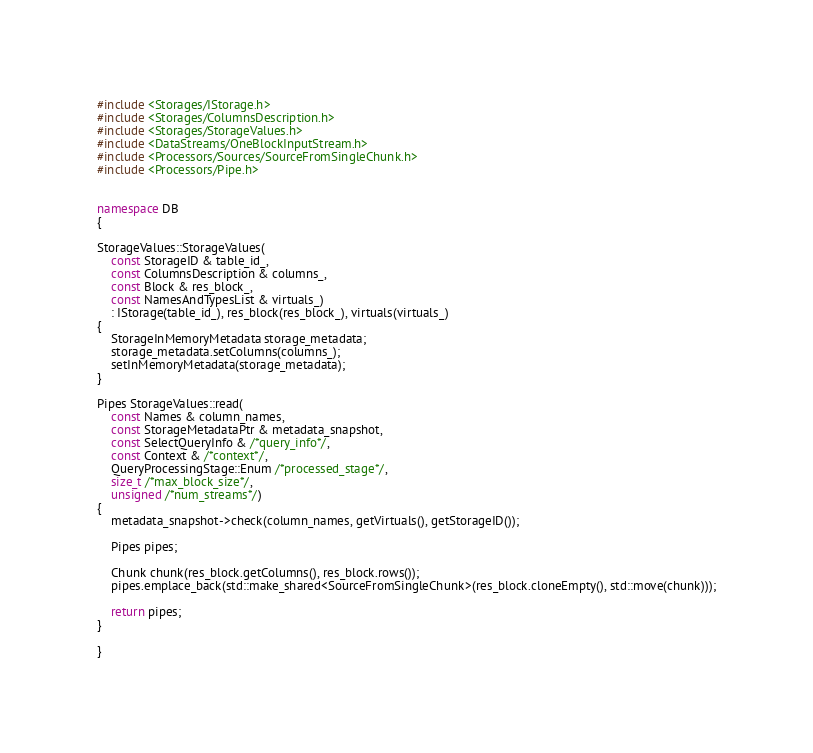<code> <loc_0><loc_0><loc_500><loc_500><_C++_>#include <Storages/IStorage.h>
#include <Storages/ColumnsDescription.h>
#include <Storages/StorageValues.h>
#include <DataStreams/OneBlockInputStream.h>
#include <Processors/Sources/SourceFromSingleChunk.h>
#include <Processors/Pipe.h>


namespace DB
{

StorageValues::StorageValues(
    const StorageID & table_id_,
    const ColumnsDescription & columns_,
    const Block & res_block_,
    const NamesAndTypesList & virtuals_)
    : IStorage(table_id_), res_block(res_block_), virtuals(virtuals_)
{
    StorageInMemoryMetadata storage_metadata;
    storage_metadata.setColumns(columns_);
    setInMemoryMetadata(storage_metadata);
}

Pipes StorageValues::read(
    const Names & column_names,
    const StorageMetadataPtr & metadata_snapshot,
    const SelectQueryInfo & /*query_info*/,
    const Context & /*context*/,
    QueryProcessingStage::Enum /*processed_stage*/,
    size_t /*max_block_size*/,
    unsigned /*num_streams*/)
{
    metadata_snapshot->check(column_names, getVirtuals(), getStorageID());

    Pipes pipes;

    Chunk chunk(res_block.getColumns(), res_block.rows());
    pipes.emplace_back(std::make_shared<SourceFromSingleChunk>(res_block.cloneEmpty(), std::move(chunk)));

    return pipes;
}

}
</code> 